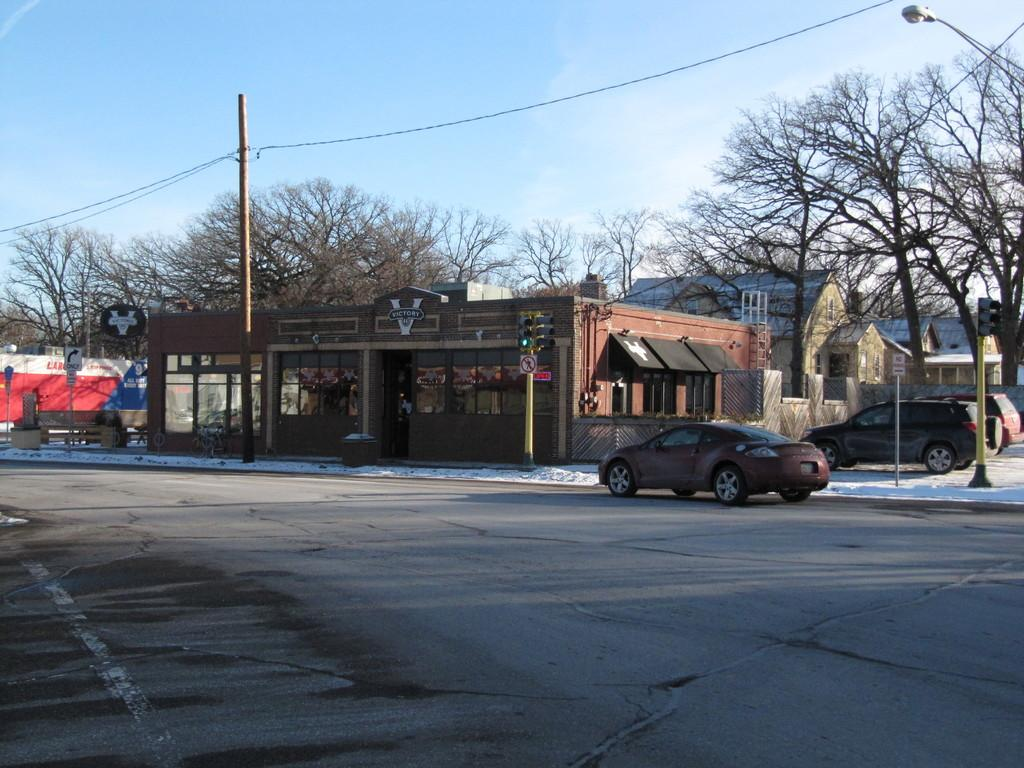What type of vehicles can be seen in the image? There are vehicles in the image, but the specific type is not mentioned. What is the weather condition in the image? There is snow in the image, indicating a cold or wintery environment. What are the poles used for in the image? The poles are likely used to support cables, as both are present in the image. What can be seen attached to the poles? Cables are attached to the poles in the image. What type of structures are visible in the image? There are boards and buildings in the image. What type of vegetation is present in the image? There are trees in the image. What is visible in the background of the image? The sky is visible in the background of the image. Are there any slaves visible in the image? There is no mention of slaves in the image, and the term "slave" is not relevant to the context of the image. What type of flowers can be seen growing near the trees in the image? There is no mention of flowers in the image; only trees are mentioned. 